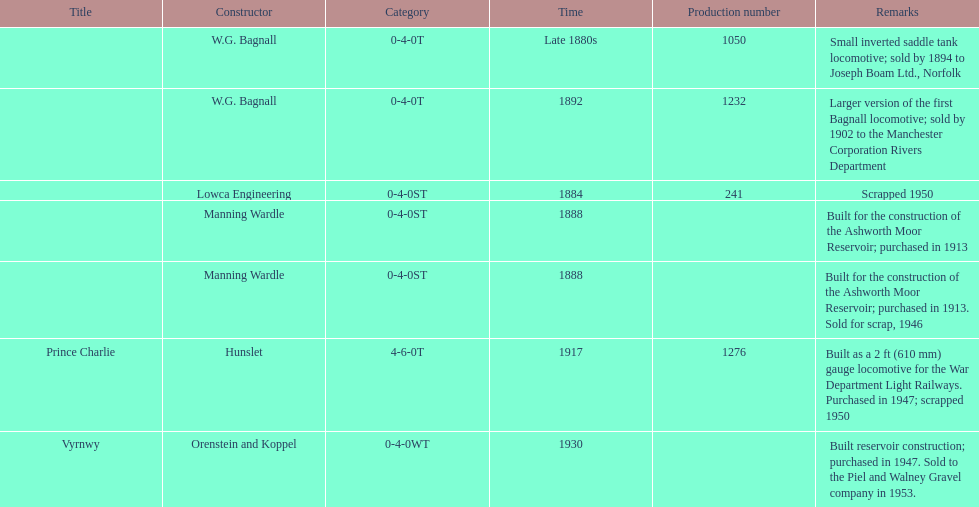List each of the builder's that had a locomotive scrapped. Lowca Engineering, Manning Wardle, Hunslet. 